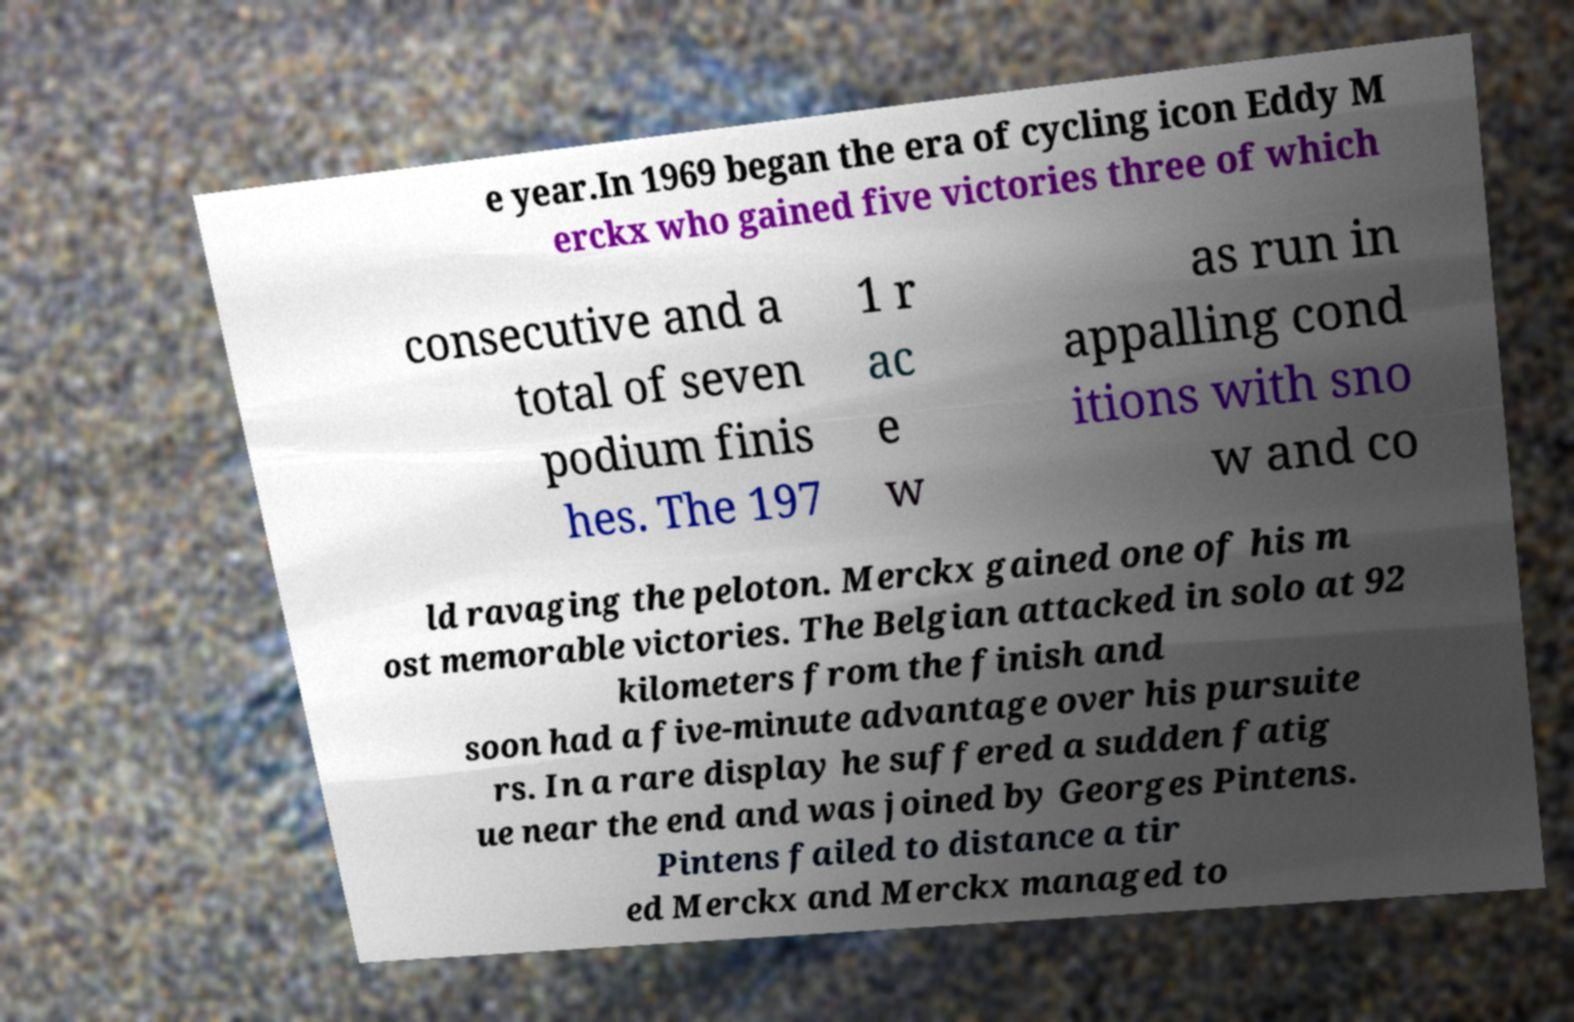Please read and relay the text visible in this image. What does it say? e year.In 1969 began the era of cycling icon Eddy M erckx who gained five victories three of which consecutive and a total of seven podium finis hes. The 197 1 r ac e w as run in appalling cond itions with sno w and co ld ravaging the peloton. Merckx gained one of his m ost memorable victories. The Belgian attacked in solo at 92 kilometers from the finish and soon had a five-minute advantage over his pursuite rs. In a rare display he suffered a sudden fatig ue near the end and was joined by Georges Pintens. Pintens failed to distance a tir ed Merckx and Merckx managed to 